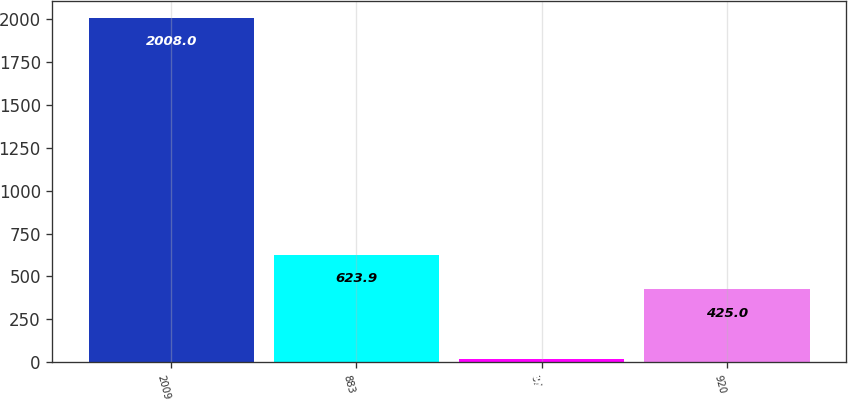Convert chart. <chart><loc_0><loc_0><loc_500><loc_500><bar_chart><fcel>2009<fcel>883<fcel>37<fcel>920<nl><fcel>2008<fcel>623.9<fcel>19<fcel>425<nl></chart> 